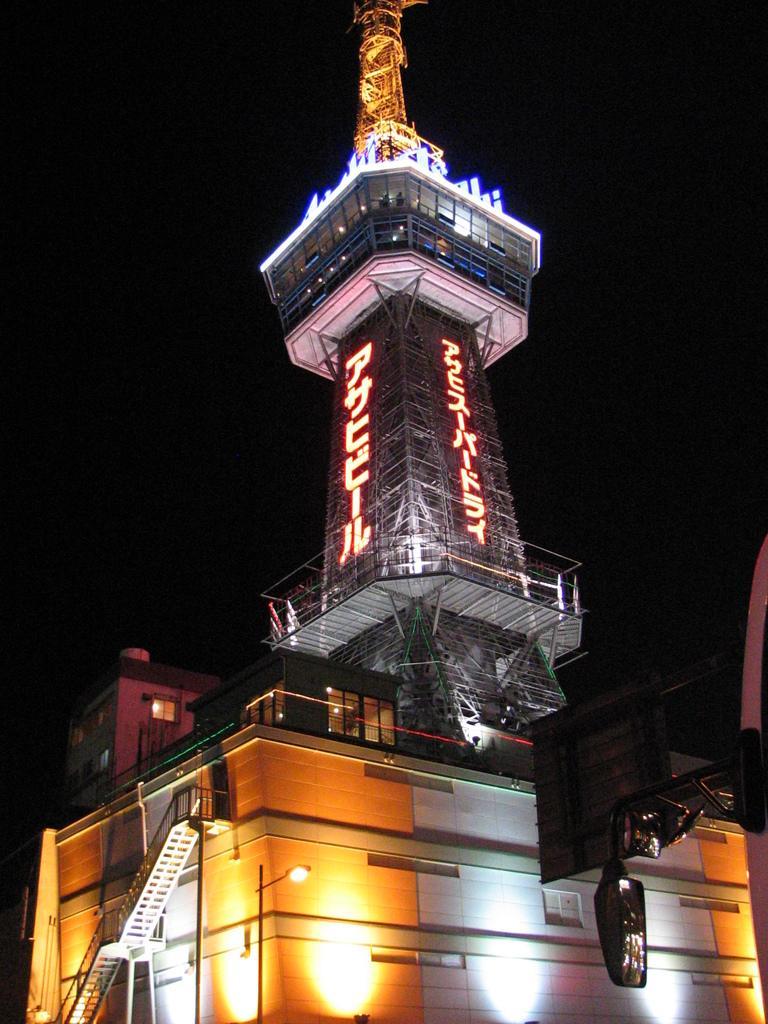In one or two sentences, can you explain what this image depicts? In this picture we can see a building, tower and few lights, we can see dark background. 